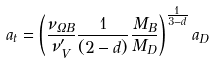Convert formula to latex. <formula><loc_0><loc_0><loc_500><loc_500>a _ { t } = \left ( \frac { \nu _ { \Omega B } } { \nu ^ { \prime } _ { V } } \frac { 1 } { ( 2 - d ) } \frac { M _ { B } } { M _ { D } } \right ) ^ { \frac { 1 } { 3 - d } } a _ { D }</formula> 